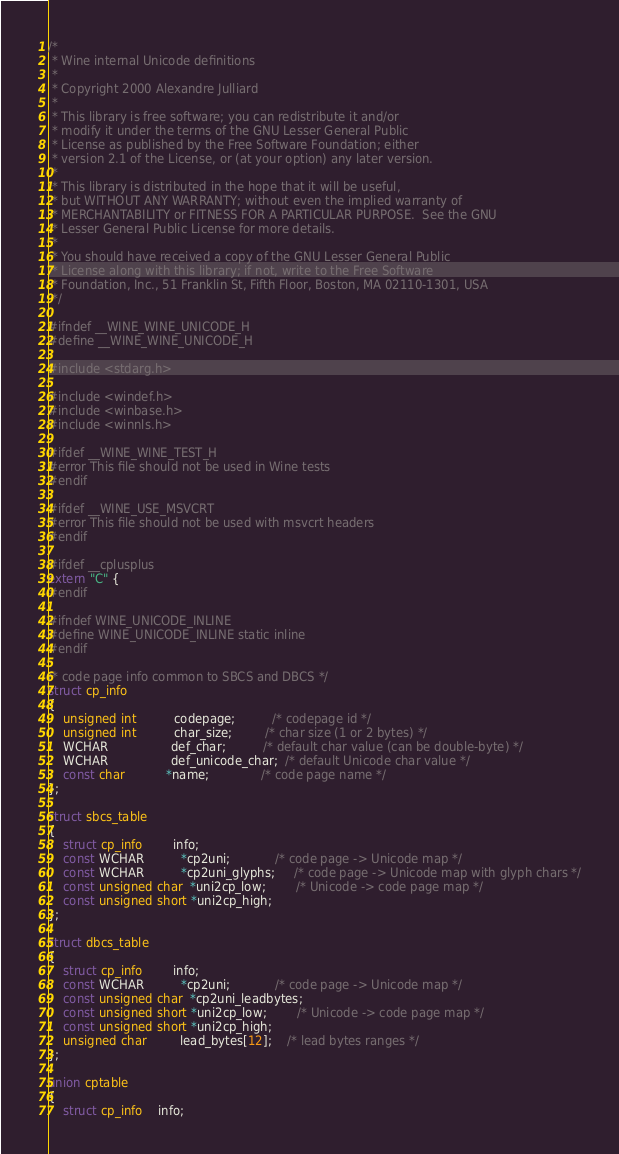Convert code to text. <code><loc_0><loc_0><loc_500><loc_500><_C_>/*
 * Wine internal Unicode definitions
 *
 * Copyright 2000 Alexandre Julliard
 *
 * This library is free software; you can redistribute it and/or
 * modify it under the terms of the GNU Lesser General Public
 * License as published by the Free Software Foundation; either
 * version 2.1 of the License, or (at your option) any later version.
 *
 * This library is distributed in the hope that it will be useful,
 * but WITHOUT ANY WARRANTY; without even the implied warranty of
 * MERCHANTABILITY or FITNESS FOR A PARTICULAR PURPOSE.  See the GNU
 * Lesser General Public License for more details.
 *
 * You should have received a copy of the GNU Lesser General Public
 * License along with this library; if not, write to the Free Software
 * Foundation, Inc., 51 Franklin St, Fifth Floor, Boston, MA 02110-1301, USA
 */

#ifndef __WINE_WINE_UNICODE_H
#define __WINE_WINE_UNICODE_H

#include <stdarg.h>

#include <windef.h>
#include <winbase.h>
#include <winnls.h>

#ifdef __WINE_WINE_TEST_H
#error This file should not be used in Wine tests
#endif

#ifdef __WINE_USE_MSVCRT
#error This file should not be used with msvcrt headers
#endif

#ifdef __cplusplus
extern "C" {
#endif

#ifndef WINE_UNICODE_INLINE
#define WINE_UNICODE_INLINE static inline
#endif

/* code page info common to SBCS and DBCS */
struct cp_info
{
    unsigned int          codepage;          /* codepage id */
    unsigned int          char_size;         /* char size (1 or 2 bytes) */
    WCHAR                 def_char;          /* default char value (can be double-byte) */
    WCHAR                 def_unicode_char;  /* default Unicode char value */
    const char           *name;              /* code page name */
};

struct sbcs_table
{
    struct cp_info        info;
    const WCHAR          *cp2uni;            /* code page -> Unicode map */
    const WCHAR          *cp2uni_glyphs;     /* code page -> Unicode map with glyph chars */
    const unsigned char  *uni2cp_low;        /* Unicode -> code page map */
    const unsigned short *uni2cp_high;
};

struct dbcs_table
{
    struct cp_info        info;
    const WCHAR          *cp2uni;            /* code page -> Unicode map */
    const unsigned char  *cp2uni_leadbytes;
    const unsigned short *uni2cp_low;        /* Unicode -> code page map */
    const unsigned short *uni2cp_high;
    unsigned char         lead_bytes[12];    /* lead bytes ranges */
};

union cptable
{
    struct cp_info    info;</code> 